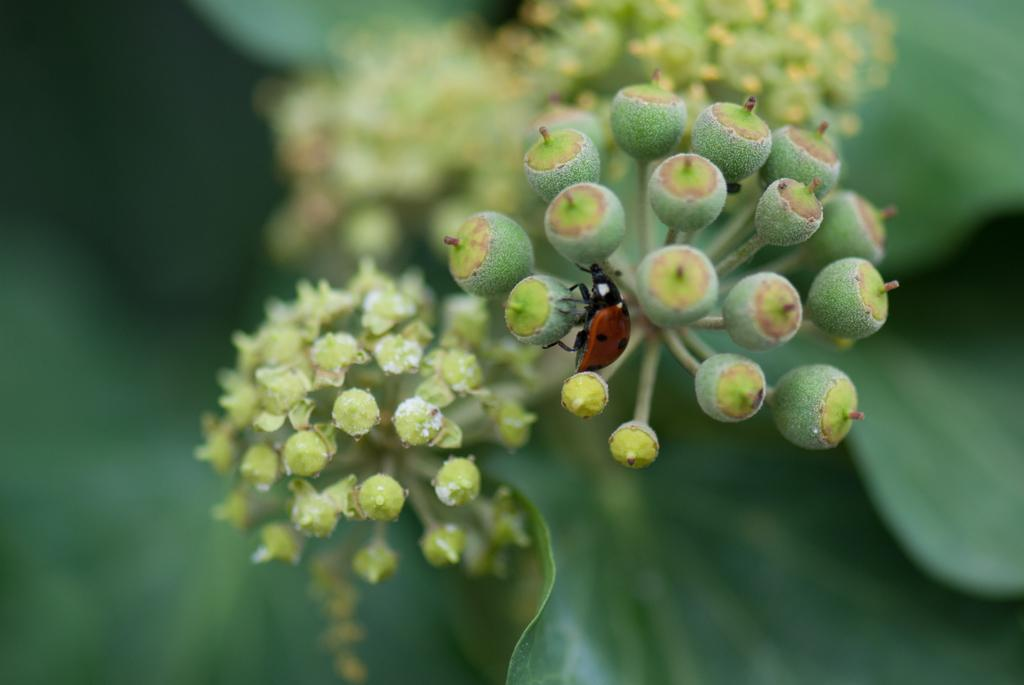What type of living organisms can be seen in the image? There are buds and an insect in the image. Can you describe the insect in the image? The insect has red and black colors. What is the background of the image like? The background of the image is blurred. What type of bean is the writer using in the image? There is no writer or bean present in the image. Can you tell me how many donkeys are visible in the image? There are no donkeys present in the image. 